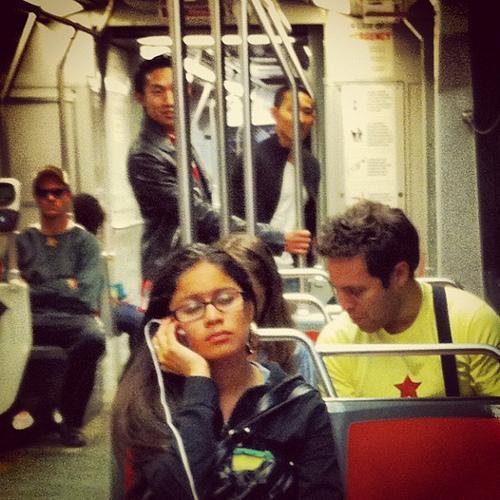How many people can you see in the image?
Give a very brief answer. 7. How many people are wearing hats?
Give a very brief answer. 1. 